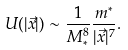Convert formula to latex. <formula><loc_0><loc_0><loc_500><loc_500>U ( | \vec { x } | ) \sim \frac { 1 } { M _ { * } ^ { 8 } } \frac { m ^ { * } } { | \vec { x } | ^ { 7 } } .</formula> 